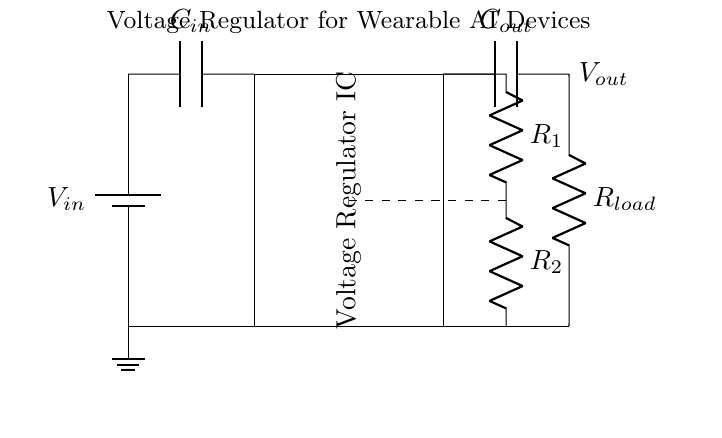What is the input voltage of this circuit? The input voltage is labeled as V_in, which is the voltage supplied to the circuit from the battery.
Answer: V_in What is the purpose of capacitor C_in? Capacitor C_in serves to filter the input voltage by smoothing out any fluctuations, thus providing a stable input to the voltage regulator.
Answer: Smoothing What is the function of the voltage regulator IC? The voltage regulator IC maintains a constant output voltage (V_out) despite variations in input voltage (V_in) or load current (R_load) conditions.
Answer: Regulation What are R_1 and R_2 used for in this circuit? Resistors R_1 and R_2 form a feedback network that sets the output voltage by controlling the regulation characteristics of the voltage regulator.
Answer: Feedback What is the value of the load resistor? The load resistor is indicated as R_load, which represents the device or circuit that draws current from the voltage output. The specific value may not be defined in this circuit but signifies a load.
Answer: R_load Explain how the output voltage is determined in this circuit. The output voltage V_out is influenced by the feedback resistors R_1 and R_2 and is determined by their ratio, in combination with the voltage regulator's internal specifications, ensuring a stable output regardless of variations in input or load.
Answer: Feedback ratio What happens if capacitor C_out is removed from the circuit? Removing capacitor C_out could lead to instability in V_out by allowing more ripple and fluctuations to occur, particularly under varying load conditions, which may affect the functionality of wearable AI devices.
Answer: Instability 